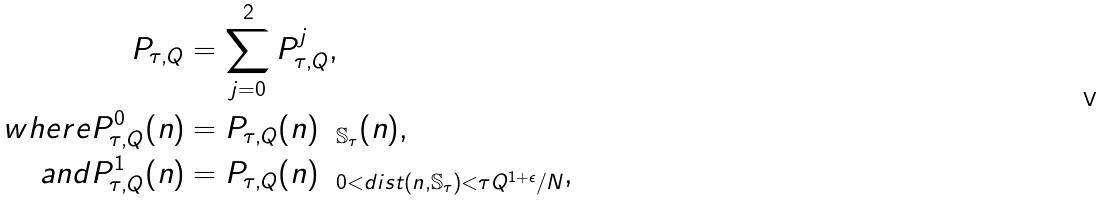<formula> <loc_0><loc_0><loc_500><loc_500>P _ { \tau , Q } & = \sum _ { j = 0 } ^ { 2 } P _ { \tau , Q } ^ { j } , \\ w h e r e P _ { \tau , Q } ^ { 0 } ( n ) & = P _ { \tau , Q } ( n ) \mathbf 1 _ { \mathbb { S } _ { \tau } } ( n ) , \\ a n d P _ { \tau , Q } ^ { 1 } ( n ) & = P _ { \tau , Q } ( n ) \mathbf 1 _ { 0 < d i s t ( n , \mathbb { S } _ { \tau } ) < \tau Q ^ { 1 + \epsilon } / N } ,</formula> 